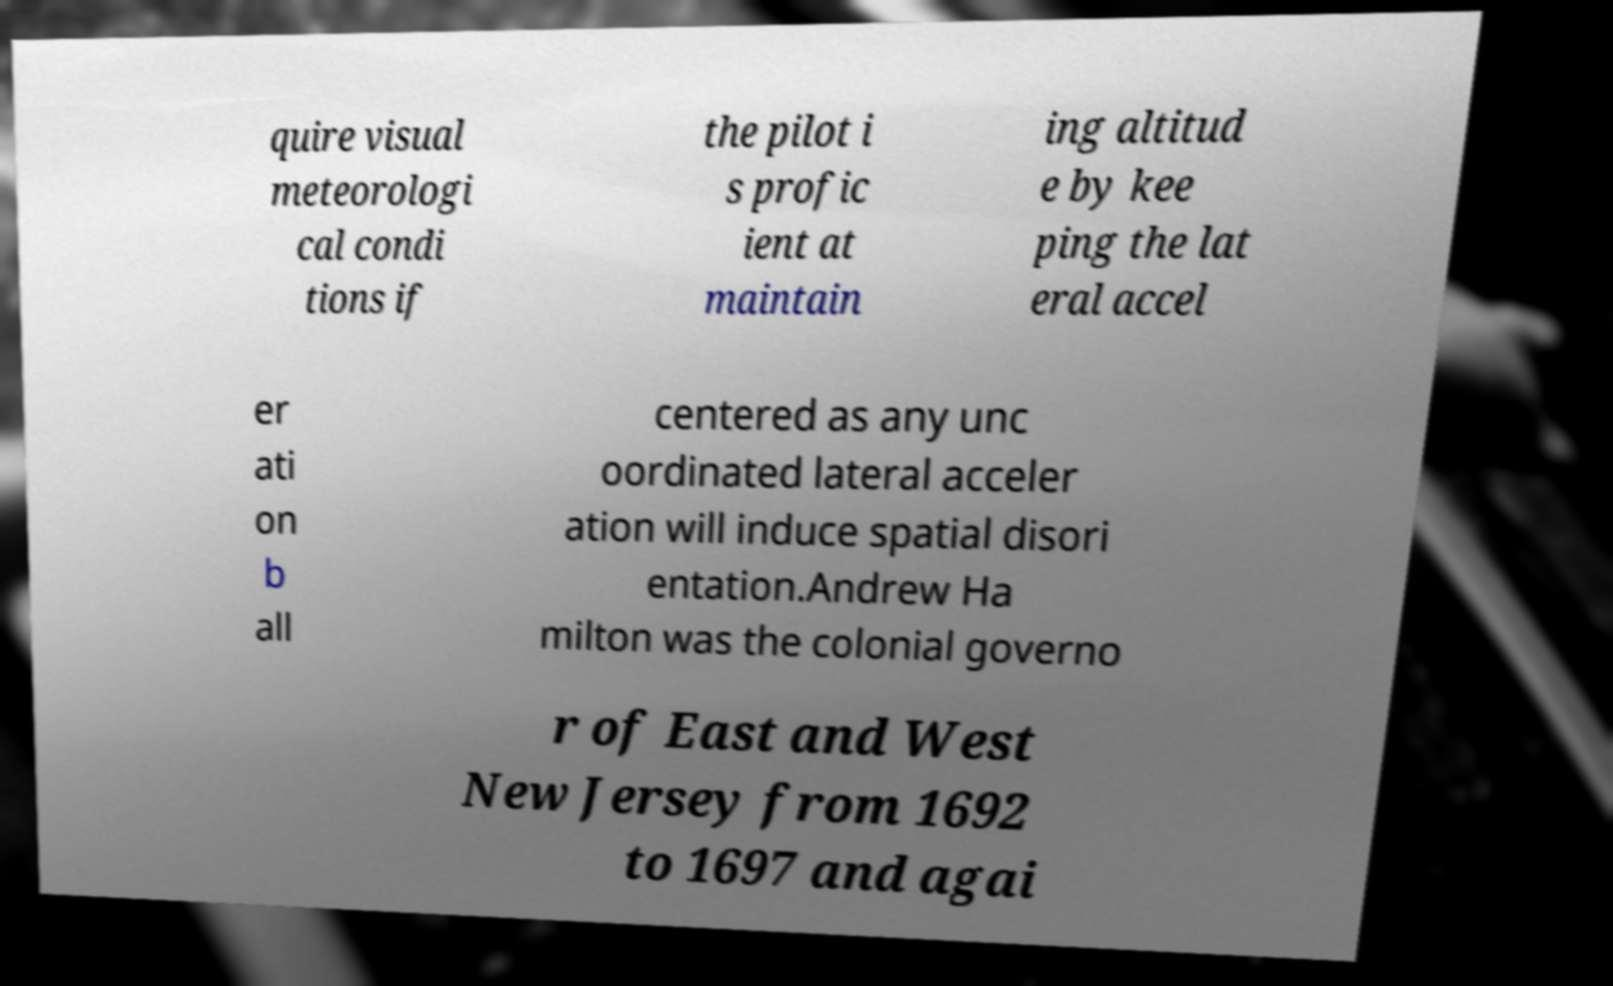Could you assist in decoding the text presented in this image and type it out clearly? quire visual meteorologi cal condi tions if the pilot i s profic ient at maintain ing altitud e by kee ping the lat eral accel er ati on b all centered as any unc oordinated lateral acceler ation will induce spatial disori entation.Andrew Ha milton was the colonial governo r of East and West New Jersey from 1692 to 1697 and agai 